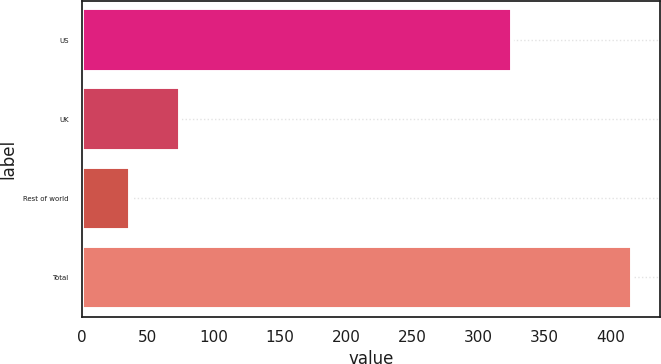Convert chart to OTSL. <chart><loc_0><loc_0><loc_500><loc_500><bar_chart><fcel>US<fcel>UK<fcel>Rest of world<fcel>Total<nl><fcel>324.9<fcel>74.56<fcel>36.6<fcel>416.2<nl></chart> 